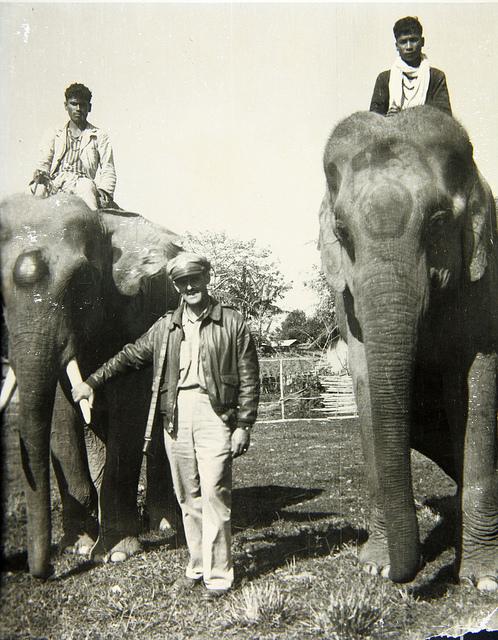How many elephants are there?
Be succinct. 2. What continent was this taken on?
Answer briefly. Africa. What are the men doing on the backs of the elephants?
Short answer required. Riding. 